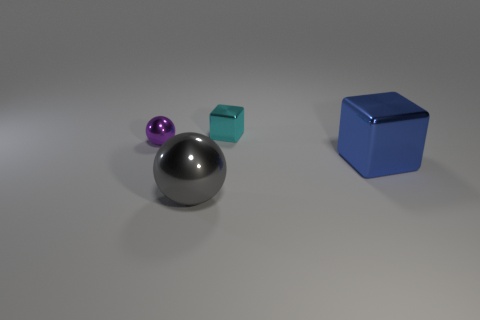How many other purple shiny objects have the same shape as the purple metallic object?
Give a very brief answer. 0. How many large metal balls are there?
Give a very brief answer. 1. What size is the thing that is behind the blue object and in front of the small cyan thing?
Keep it short and to the point. Small. There is a purple metallic object that is the same size as the cyan thing; what shape is it?
Provide a succinct answer. Sphere. Are there any big gray metal objects that are behind the metallic object to the right of the tiny cyan shiny thing?
Offer a very short reply. No. What is the color of the other metal object that is the same shape as the tiny purple thing?
Provide a short and direct response. Gray. There is a large thing that is behind the gray metallic thing; does it have the same color as the big sphere?
Your answer should be compact. No. How many objects are either cubes that are behind the purple sphere or big blue cylinders?
Provide a succinct answer. 1. There is a block that is to the right of the small thing that is to the right of the metal ball that is in front of the tiny purple sphere; what is it made of?
Offer a very short reply. Metal. Is the number of cyan metallic cubes in front of the large blue metal cube greater than the number of large spheres right of the tiny cyan cube?
Offer a very short reply. No. 